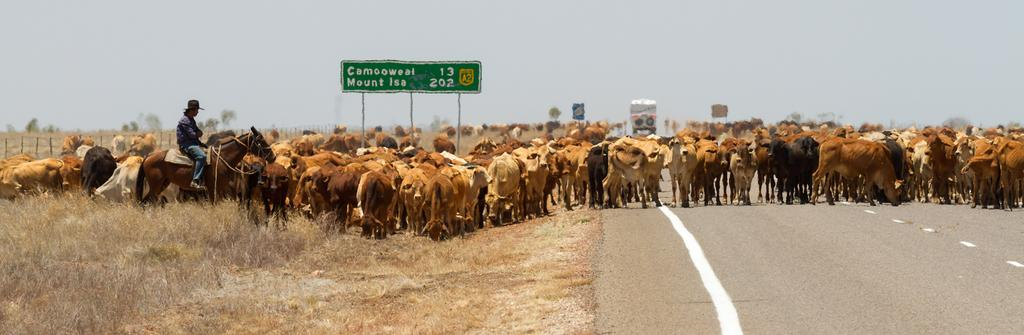What is the person in the image doing? The person is sitting on a horse in the image. What other living creatures can be seen in the image? There are animals in the image. What type of terrain is visible in the image? There is grass in the image. What structures can be seen in the background? There are boards on poles and a fence in the background. What type of vegetation is visible in the background? There are trees in the background. What else can be seen in the background? There is a vehicle and the sky visible in the background. Where is the sand visible in the image? There is no sand visible in the image. What type of bird is building a nest in the image? There is no bird or nest present in the image. 